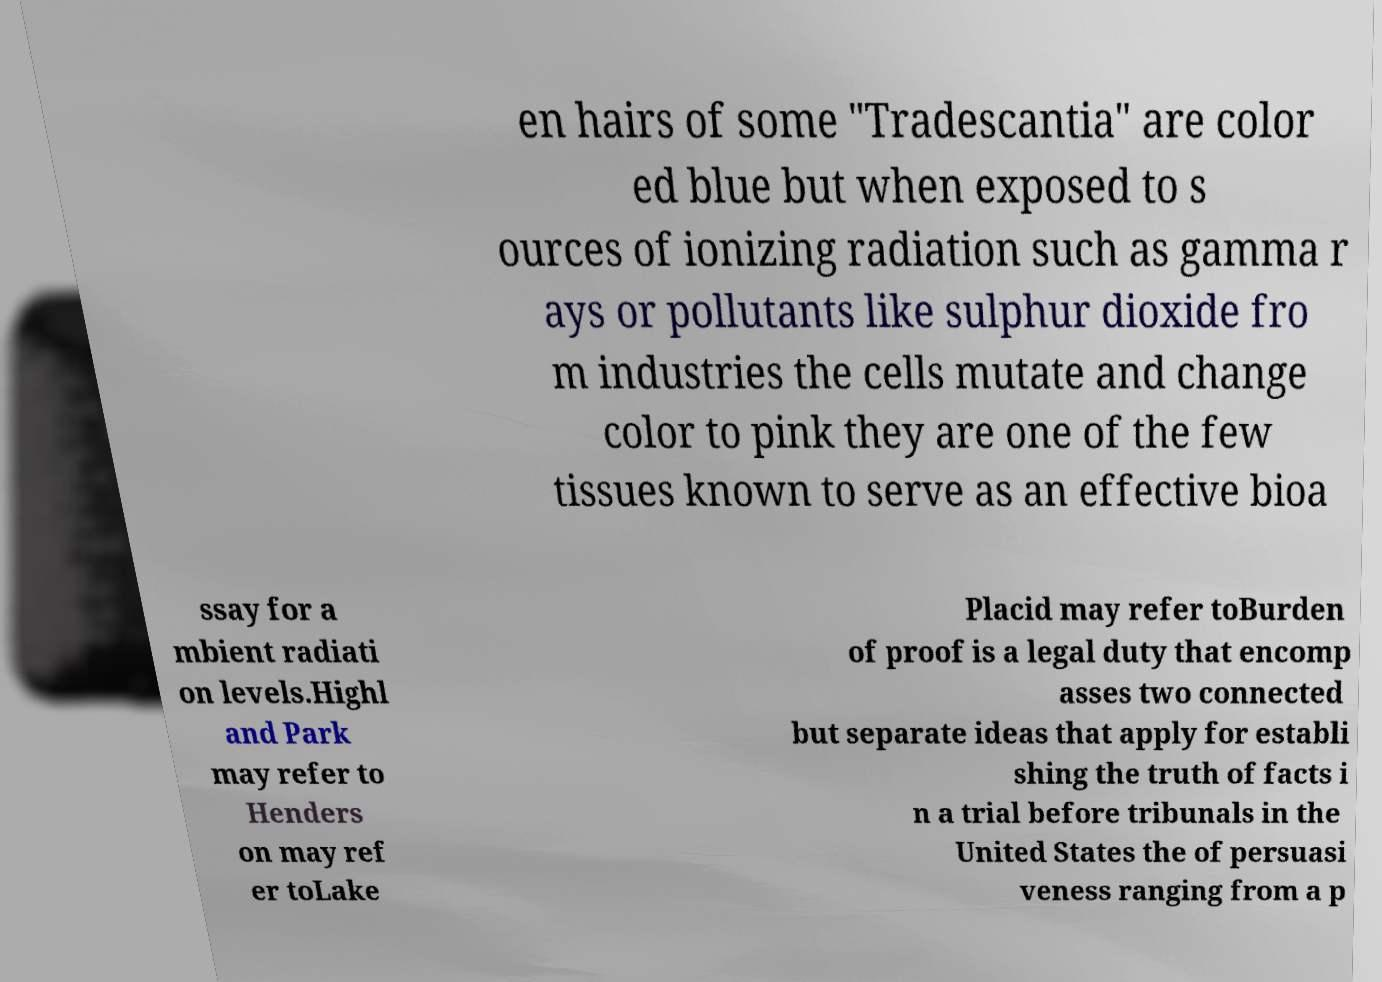Could you assist in decoding the text presented in this image and type it out clearly? en hairs of some "Tradescantia" are color ed blue but when exposed to s ources of ionizing radiation such as gamma r ays or pollutants like sulphur dioxide fro m industries the cells mutate and change color to pink they are one of the few tissues known to serve as an effective bioa ssay for a mbient radiati on levels.Highl and Park may refer to Henders on may ref er toLake Placid may refer toBurden of proof is a legal duty that encomp asses two connected but separate ideas that apply for establi shing the truth of facts i n a trial before tribunals in the United States the of persuasi veness ranging from a p 